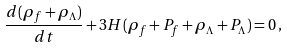<formula> <loc_0><loc_0><loc_500><loc_500>\frac { d ( { \rho } _ { f } + \rho _ { \Lambda } ) } { d t } + 3 H ( \rho _ { f } + P _ { f } + \rho _ { \Lambda } + P _ { \Lambda } ) = 0 \, ,</formula> 